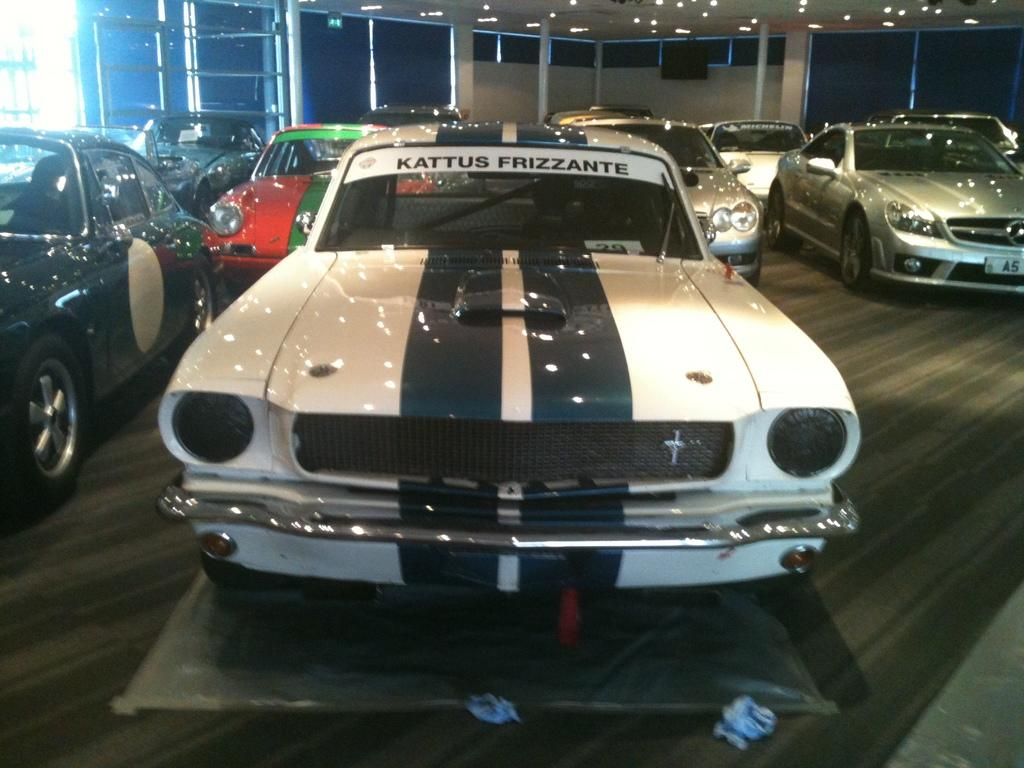What types of objects are present in the image? There are vehicles in the image. Where are the vehicles located? The vehicles are on a surface. What else can be seen at the top of the image? There are lights visible at the top of the image. What type of plot is being advertised in the image? There is no plot or advertisement present in the image; it features vehicles on a surface with lights visible at the top. 